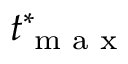<formula> <loc_0><loc_0><loc_500><loc_500>t _ { \max } ^ { * }</formula> 